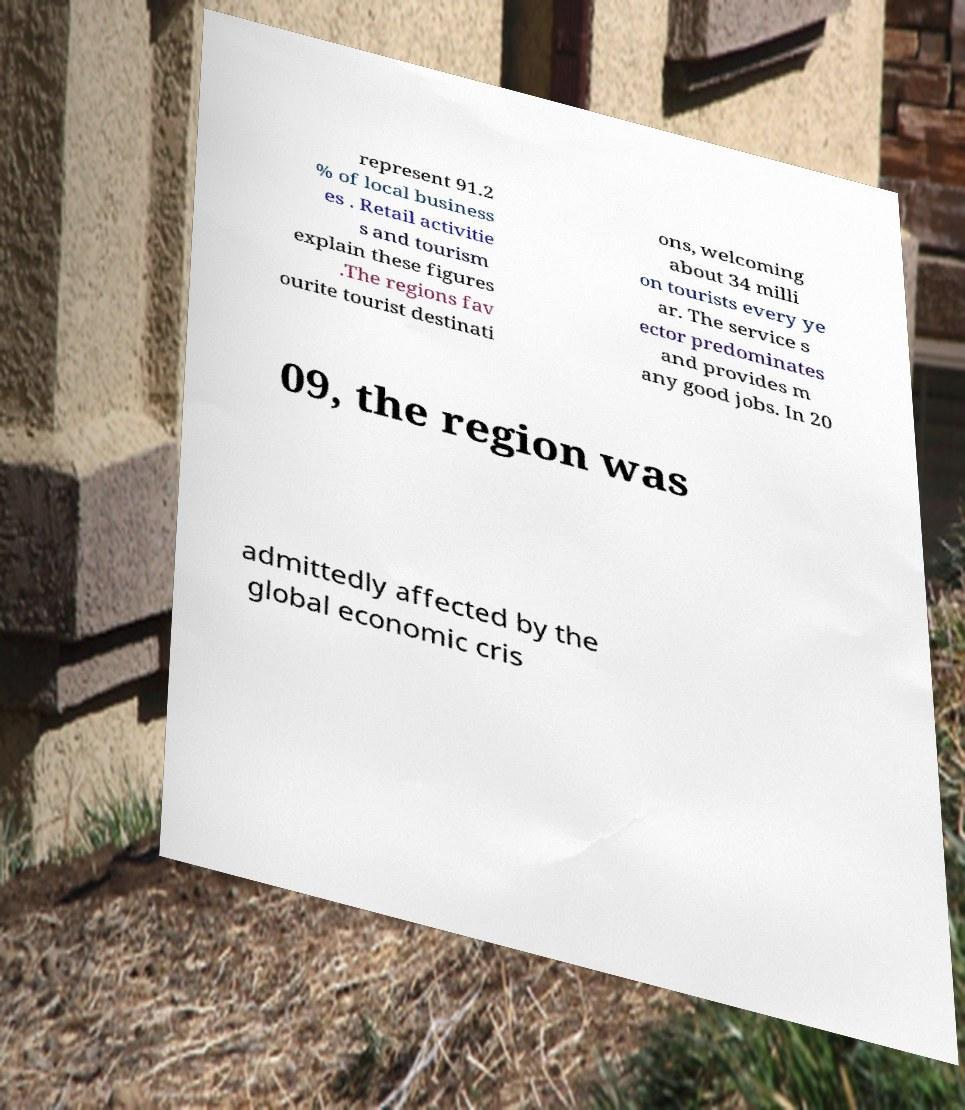Can you read and provide the text displayed in the image?This photo seems to have some interesting text. Can you extract and type it out for me? represent 91.2 % of local business es . Retail activitie s and tourism explain these figures .The regions fav ourite tourist destinati ons, welcoming about 34 milli on tourists every ye ar. The service s ector predominates and provides m any good jobs. In 20 09, the region was admittedly affected by the global economic cris 